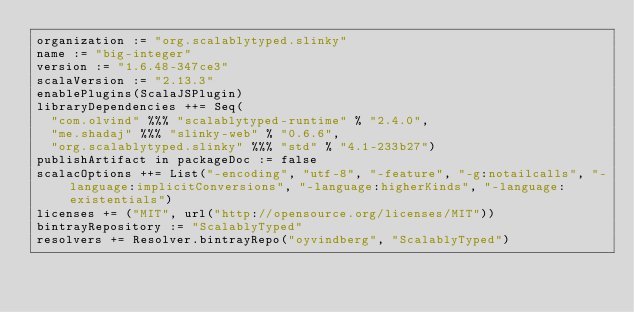<code> <loc_0><loc_0><loc_500><loc_500><_Scala_>organization := "org.scalablytyped.slinky"
name := "big-integer"
version := "1.6.48-347ce3"
scalaVersion := "2.13.3"
enablePlugins(ScalaJSPlugin)
libraryDependencies ++= Seq(
  "com.olvind" %%% "scalablytyped-runtime" % "2.4.0",
  "me.shadaj" %%% "slinky-web" % "0.6.6",
  "org.scalablytyped.slinky" %%% "std" % "4.1-233b27")
publishArtifact in packageDoc := false
scalacOptions ++= List("-encoding", "utf-8", "-feature", "-g:notailcalls", "-language:implicitConversions", "-language:higherKinds", "-language:existentials")
licenses += ("MIT", url("http://opensource.org/licenses/MIT"))
bintrayRepository := "ScalablyTyped"
resolvers += Resolver.bintrayRepo("oyvindberg", "ScalablyTyped")
</code> 